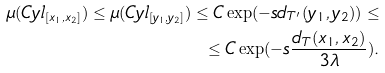Convert formula to latex. <formula><loc_0><loc_0><loc_500><loc_500>\mu ( C y l _ { [ x _ { 1 } , x _ { 2 } ] } ) \leq \mu ( C y l _ { [ y _ { 1 } , y _ { 2 } ] } ) \leq C \exp ( - s d _ { T ^ { \prime } } ( y _ { 1 } , y _ { 2 } ) ) \leq \\ \leq C \exp ( - s \frac { d _ { T } ( x _ { 1 } , x _ { 2 } ) } { 3 \lambda } ) .</formula> 